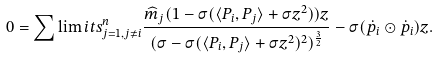<formula> <loc_0><loc_0><loc_500><loc_500>0 = \sum \lim i t s _ { j = 1 , j \neq i } ^ { n } \frac { \widehat { m } _ { j } ( 1 - \sigma ( \langle P _ { i } , P _ { j } \rangle + \sigma z ^ { 2 } ) ) z } { ( \sigma - \sigma ( \langle P _ { i } , P _ { j } \rangle + \sigma z ^ { 2 } ) ^ { 2 } ) ^ { \frac { 3 } { 2 } } } - \sigma ( \dot { p } _ { i } \odot \dot { p } _ { i } ) z .</formula> 